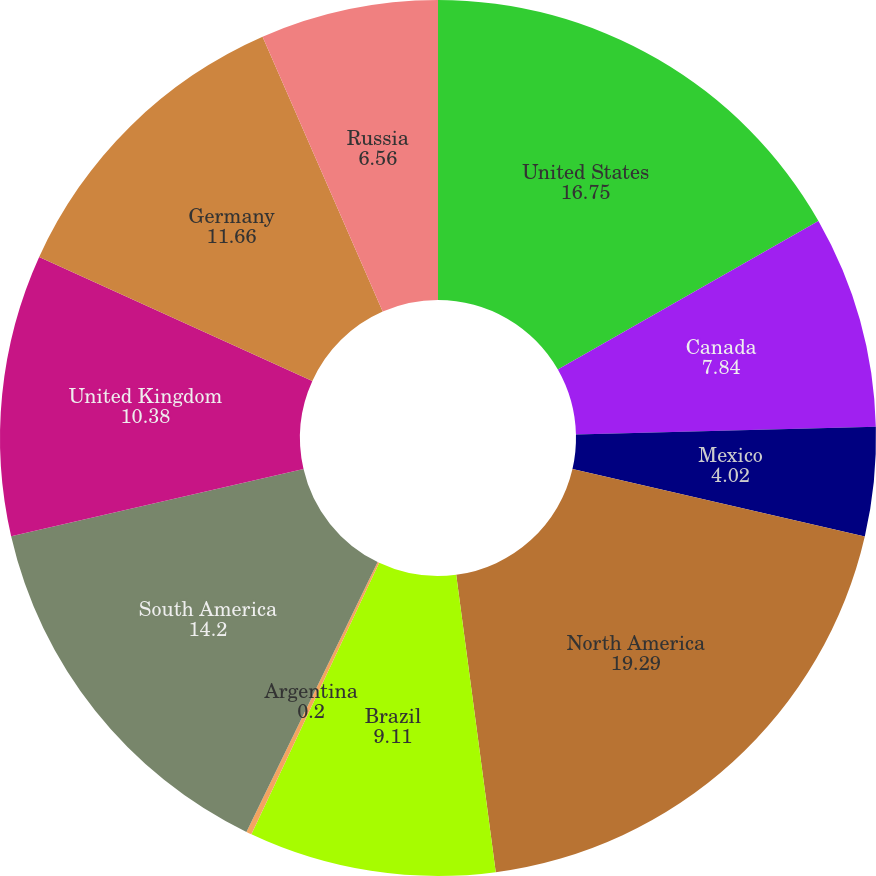Convert chart. <chart><loc_0><loc_0><loc_500><loc_500><pie_chart><fcel>United States<fcel>Canada<fcel>Mexico<fcel>North America<fcel>Brazil<fcel>Argentina<fcel>South America<fcel>United Kingdom<fcel>Germany<fcel>Russia<nl><fcel>16.75%<fcel>7.84%<fcel>4.02%<fcel>19.29%<fcel>9.11%<fcel>0.2%<fcel>14.2%<fcel>10.38%<fcel>11.66%<fcel>6.56%<nl></chart> 